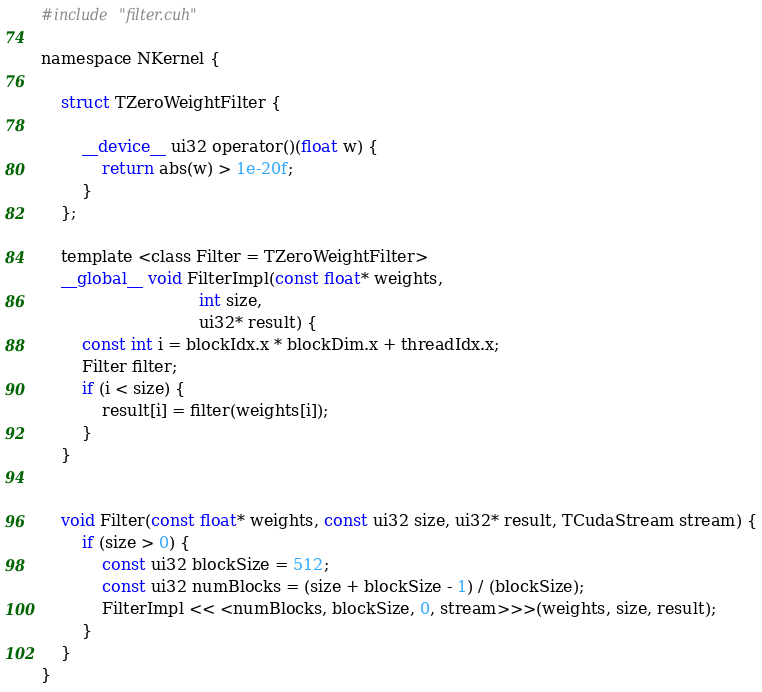<code> <loc_0><loc_0><loc_500><loc_500><_Cuda_>#include "filter.cuh"

namespace NKernel {

    struct TZeroWeightFilter {

        __device__ ui32 operator()(float w) {
            return abs(w) > 1e-20f;
        }
    };

    template <class Filter = TZeroWeightFilter>
    __global__ void FilterImpl(const float* weights,
                               int size,
                               ui32* result) {
        const int i = blockIdx.x * blockDim.x + threadIdx.x;
        Filter filter;
        if (i < size) {
            result[i] = filter(weights[i]);
        }
    }


    void Filter(const float* weights, const ui32 size, ui32* result, TCudaStream stream) {
        if (size > 0) {
            const ui32 blockSize = 512;
            const ui32 numBlocks = (size + blockSize - 1) / (blockSize);
            FilterImpl << <numBlocks, blockSize, 0, stream>>>(weights, size, result);
        }
    }
}
</code> 